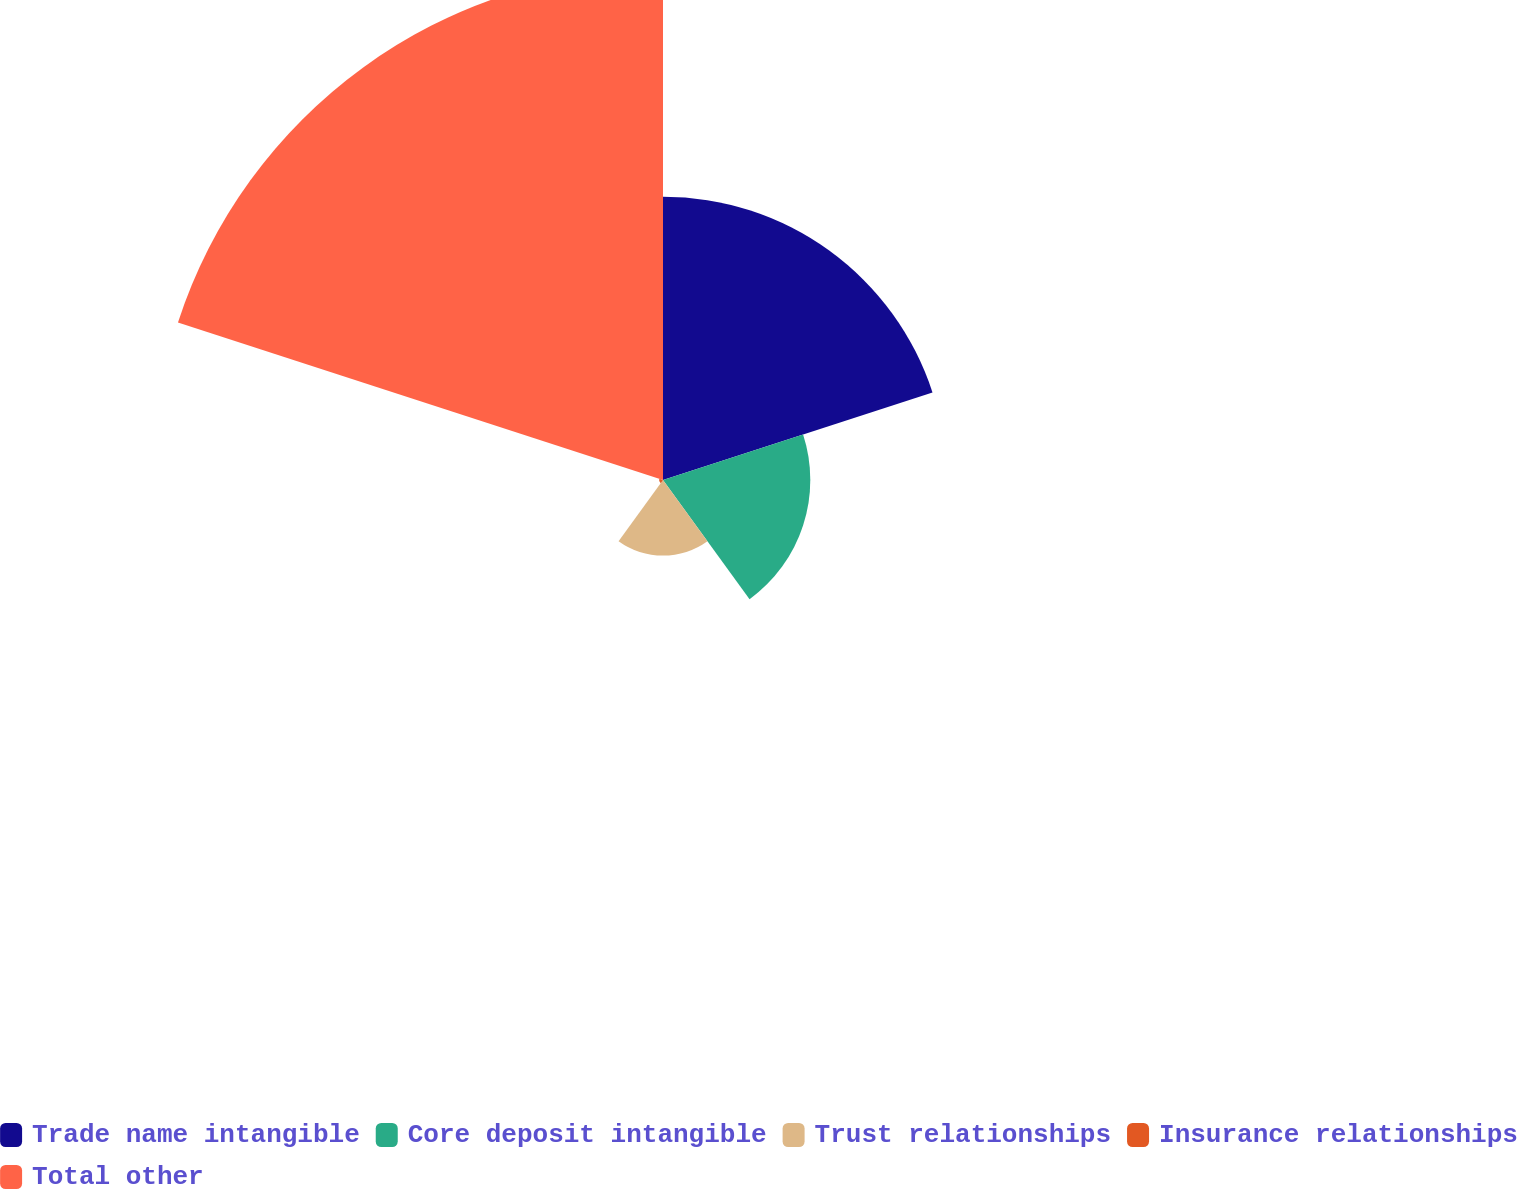<chart> <loc_0><loc_0><loc_500><loc_500><pie_chart><fcel>Trade name intangible<fcel>Core deposit intangible<fcel>Trust relationships<fcel>Insurance relationships<fcel>Total other<nl><fcel>27.78%<fcel>14.44%<fcel>7.41%<fcel>0.38%<fcel>50.0%<nl></chart> 